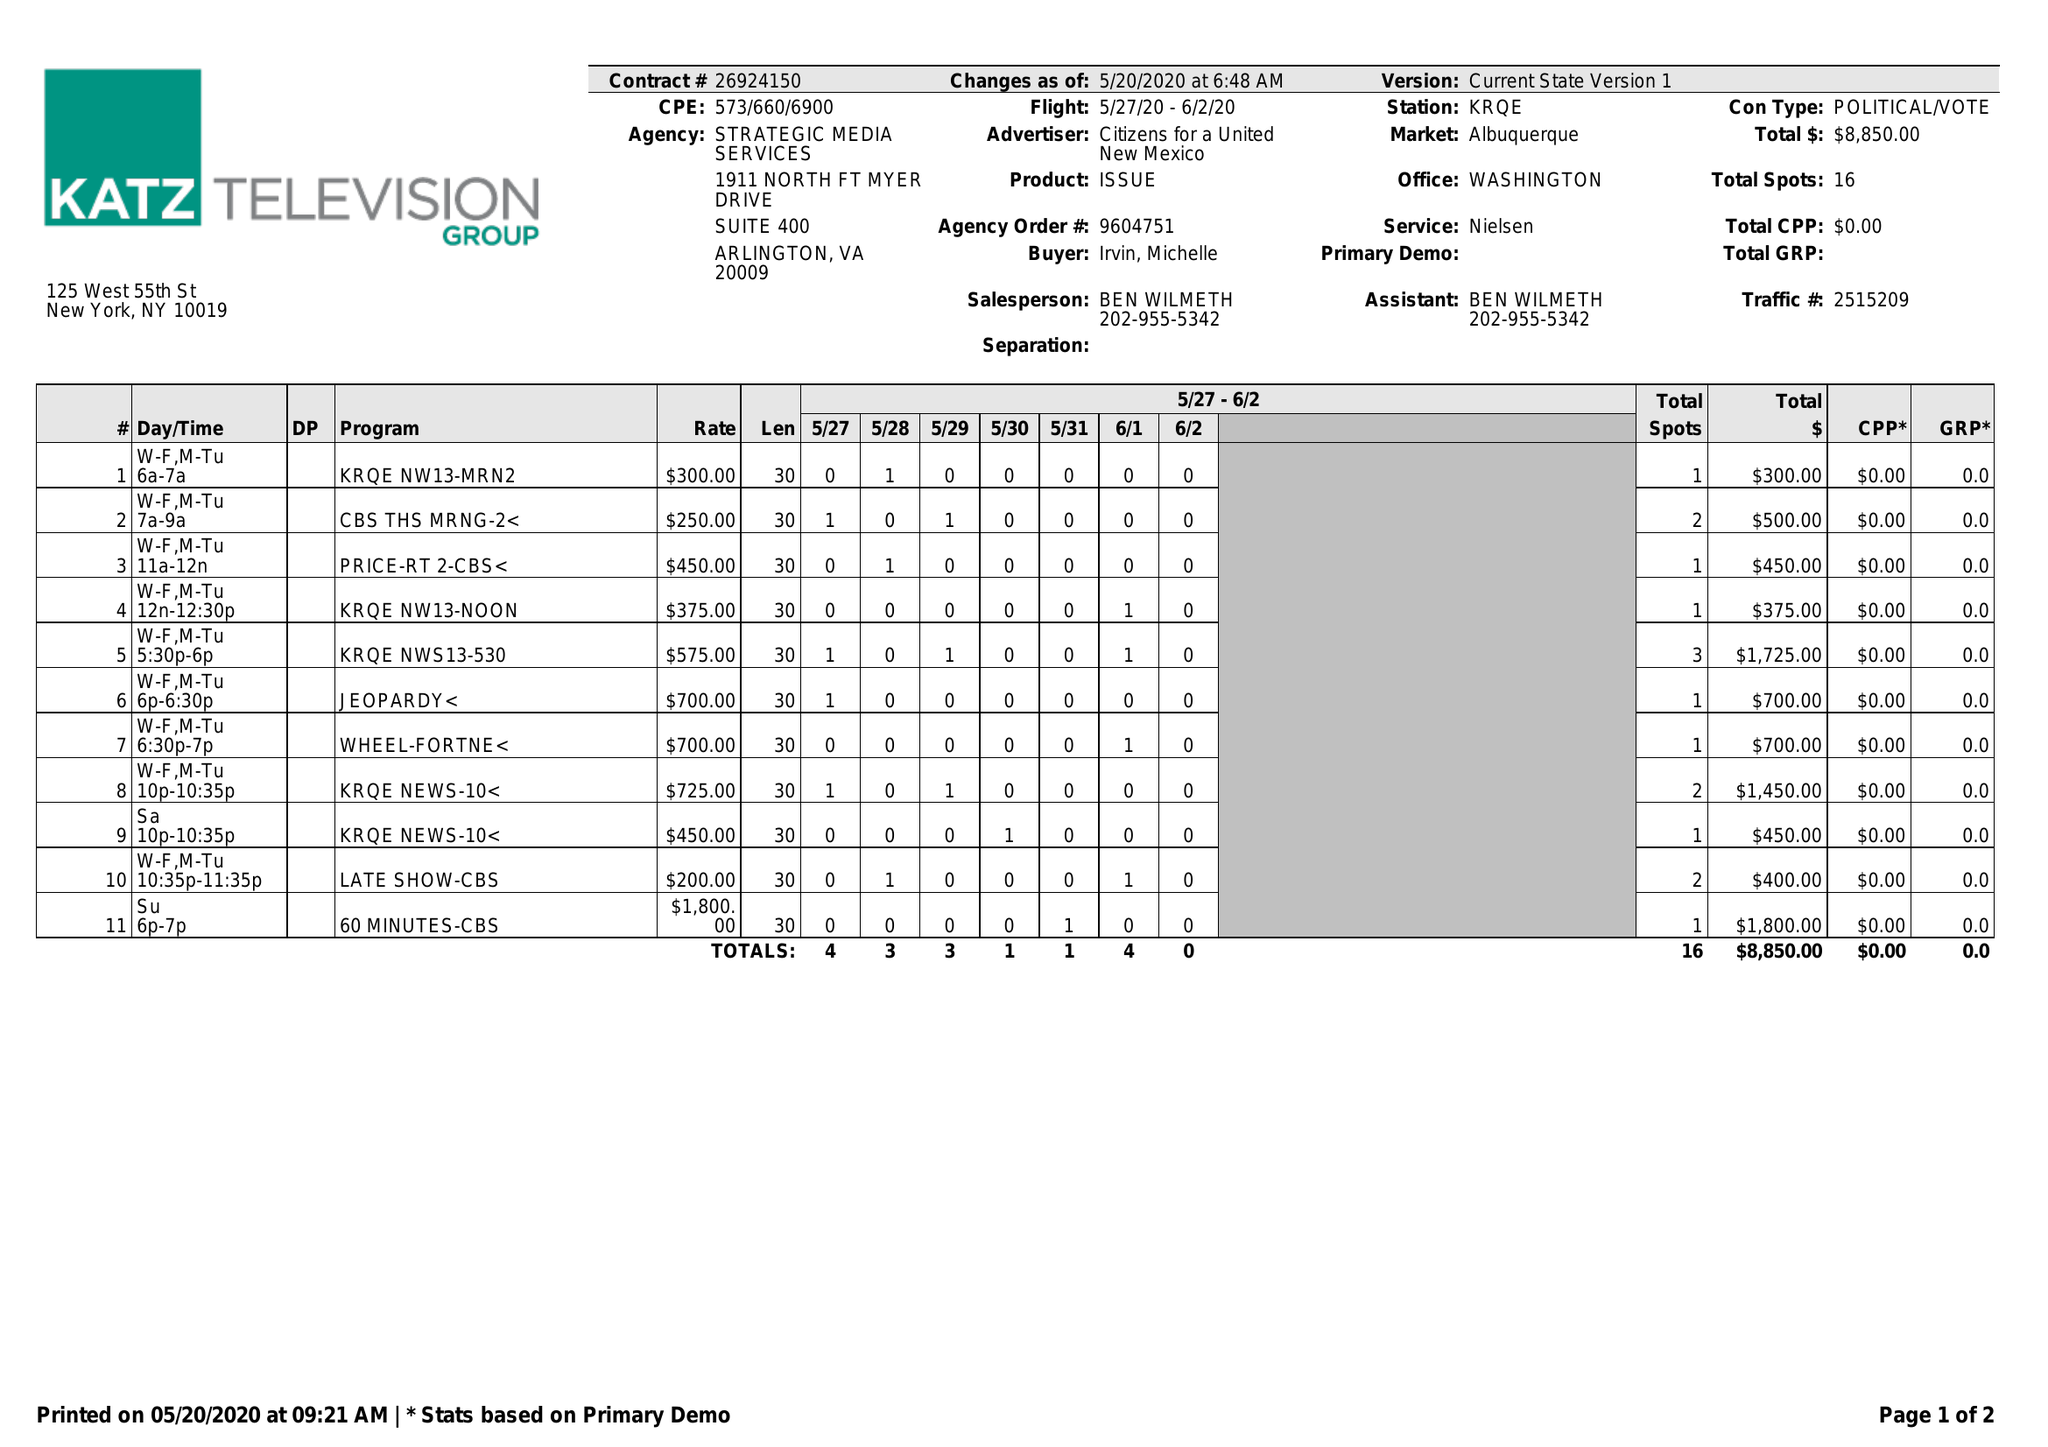What is the value for the flight_from?
Answer the question using a single word or phrase. 05/27/20 